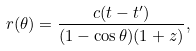Convert formula to latex. <formula><loc_0><loc_0><loc_500><loc_500>r ( \theta ) = \frac { c ( t - t ^ { \prime } ) } { ( 1 - \cos { \theta } ) ( 1 + z ) } ,</formula> 